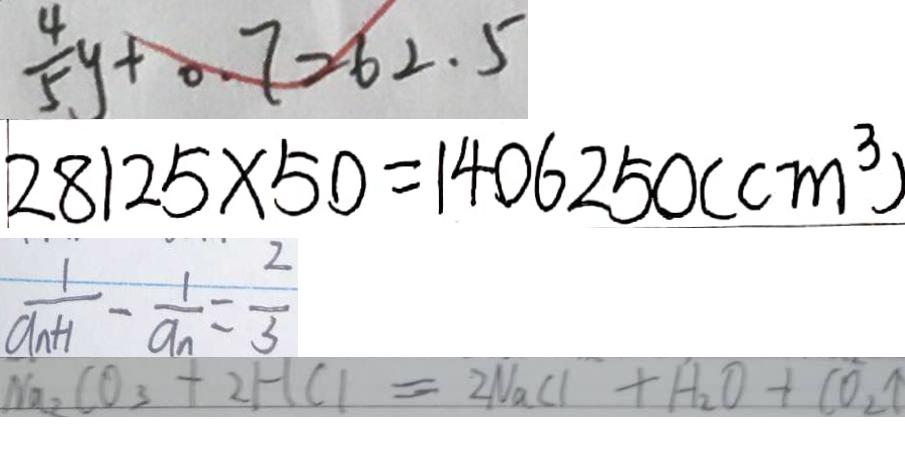<formula> <loc_0><loc_0><loc_500><loc_500>\frac { 4 } { 5 } y + 0 . 7 = 6 2 . 5 
 2 8 1 2 5 \times 5 0 = 1 4 0 6 2 5 0 ( c m ^ { 3 } ) 
 \frac { 1 } { a _ { n + 1 } } - \frac { 1 } { a _ { n } } = \frac { 2 } { 3 } 
 N a _ { 2 } C O _ { 3 } + 2 H C l = 2 N a C l + H _ { 2 } O + C O _ { 2 } \uparrow</formula> 